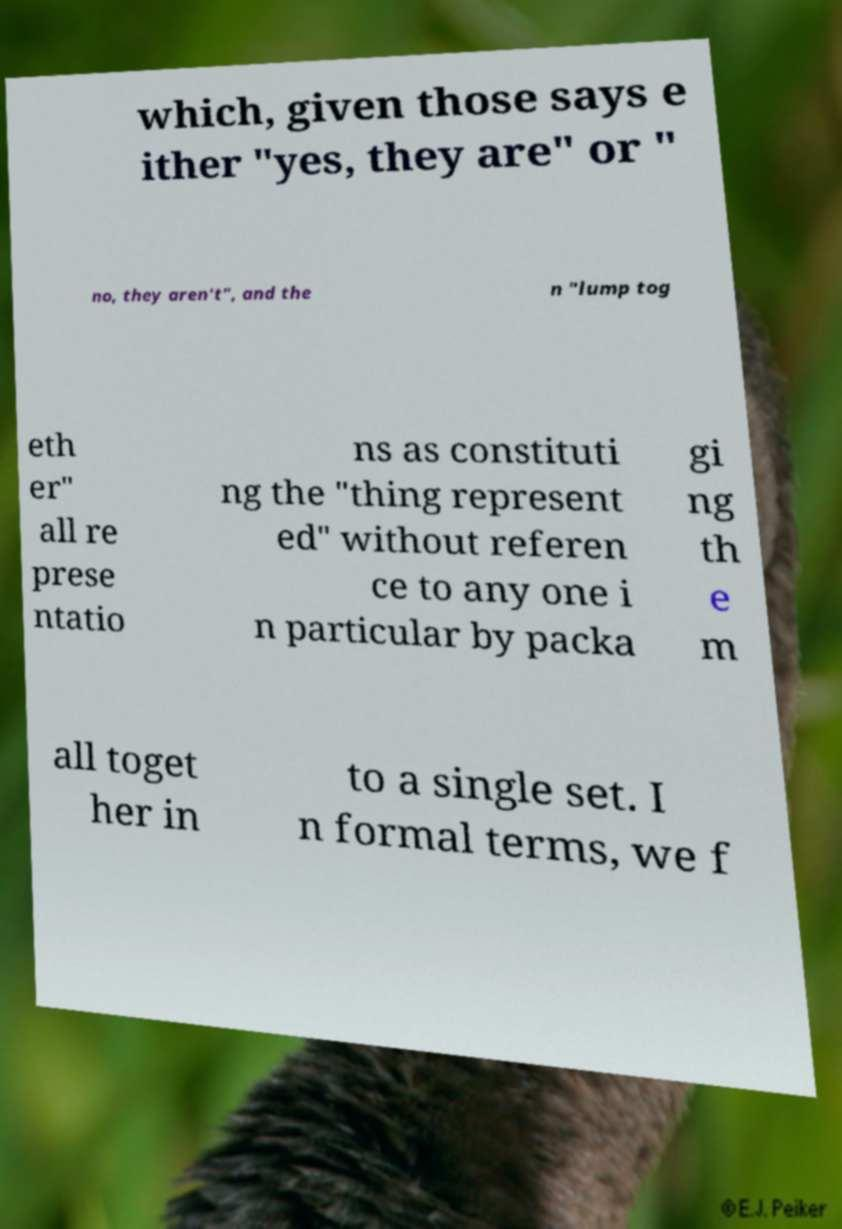Can you accurately transcribe the text from the provided image for me? which, given those says e ither "yes, they are" or " no, they aren't", and the n "lump tog eth er" all re prese ntatio ns as constituti ng the "thing represent ed" without referen ce to any one i n particular by packa gi ng th e m all toget her in to a single set. I n formal terms, we f 